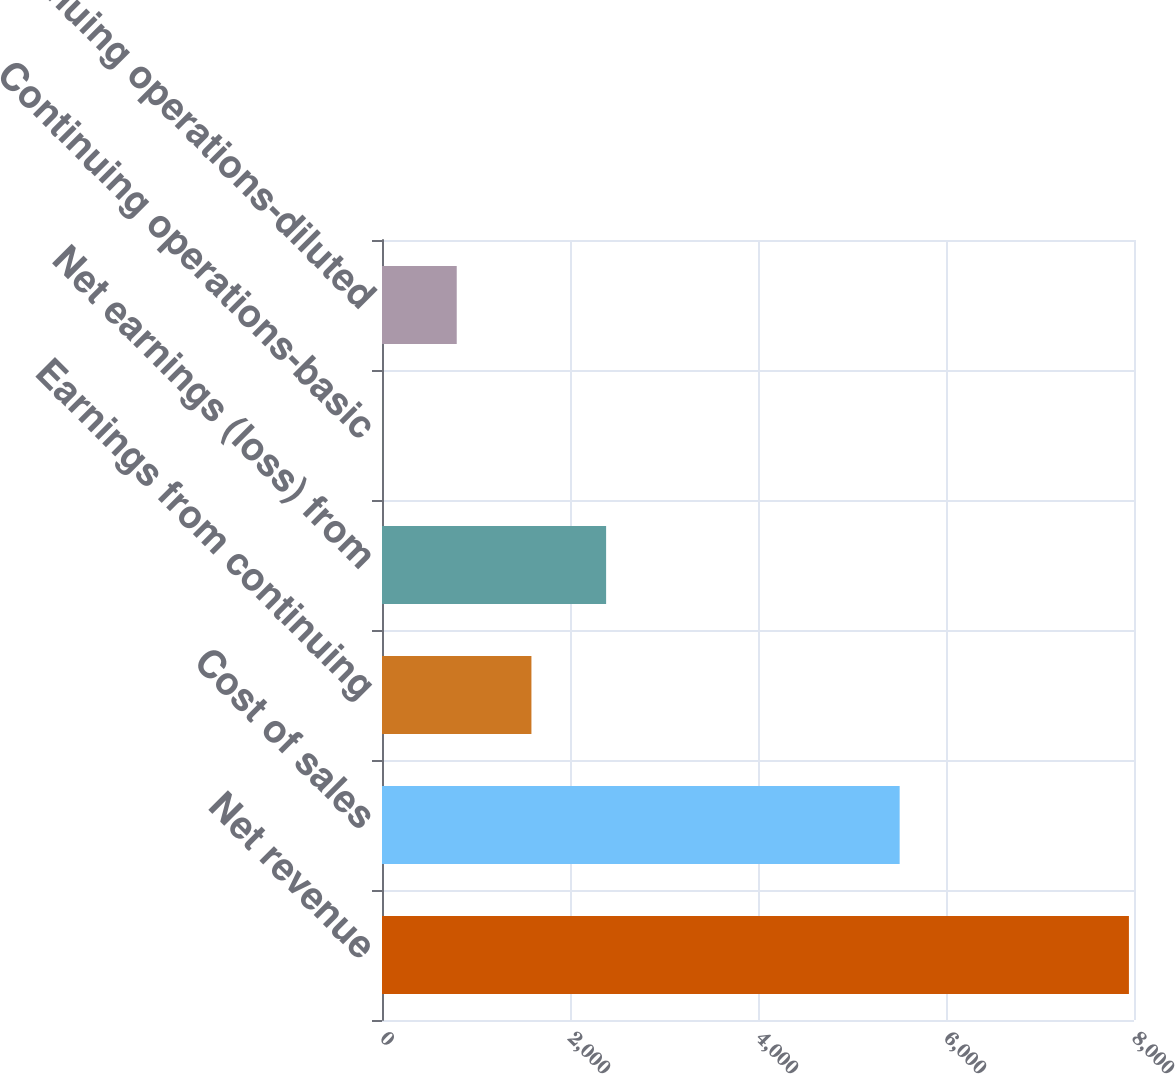Convert chart to OTSL. <chart><loc_0><loc_0><loc_500><loc_500><bar_chart><fcel>Net revenue<fcel>Cost of sales<fcel>Earnings from continuing<fcel>Net earnings (loss) from<fcel>Continuing operations-basic<fcel>Continuing operations-diluted<nl><fcel>7946<fcel>5507<fcel>1589.63<fcel>2384.18<fcel>0.53<fcel>795.08<nl></chart> 